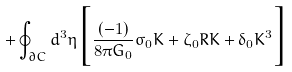Convert formula to latex. <formula><loc_0><loc_0><loc_500><loc_500>+ \oint _ { \partial C } d ^ { 3 } \eta \Big { [ } \frac { ( - 1 ) } { 8 \pi G _ { 0 } } \sigma _ { 0 } K + \zeta _ { 0 } R K + \delta _ { 0 } K ^ { 3 } \Big { ] }</formula> 